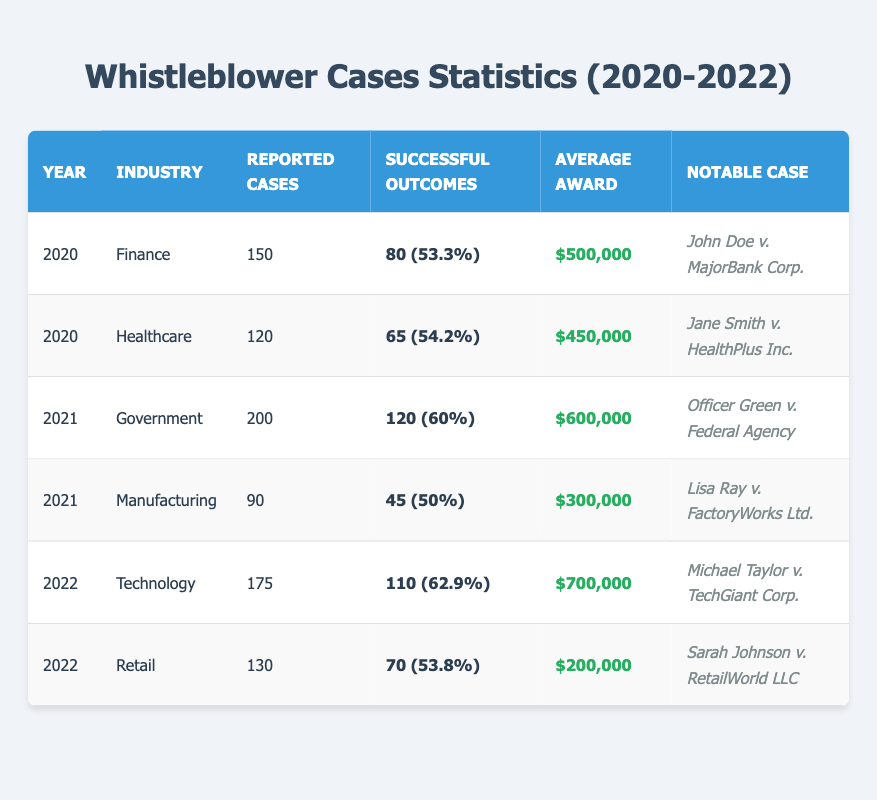What year had the highest number of reported whistleblower cases? By reviewing the "Reported Cases" column, the year 2021 shows the highest total of 200 reported cases in the Government industry.
Answer: 2021 What was the average award for whistleblower cases in 2022? Examining the "Average Award" column for the year 2022, there are two entries: $700,000 for Technology and $200,000 for Retail. To find the average, sum these amounts ($700,000 + $200,000 = $900,000) and divide by the number of cases (2), giving an average of $450,000.
Answer: $450,000 Is the success rate of the whistleblower cases in the Finance industry higher than 50% in 2020? The success rate for Finance cases in 2020 is 53.3%, which is indeed higher than 50%.
Answer: Yes How many successful outcomes were reported in the Healthcare industry in 2020? The table indicates there were 65 successful outcomes in the Healthcare industry for the year 2020.
Answer: 65 Which industry had the highest average award from 2020 to 2022? The average awards for each industry are $500,000 (Finance), $450,000 (Healthcare), $600,000 (Government), $300,000 (Manufacturing), $700,000 (Technology), and $200,000 (Retail). The highest among these is $700,000 from the Technology industry in 2022.
Answer: Technology What is the total number of reported cases across all industries in 2021? Summing reported cases from all industries for 2021 gives: 200 (Government) + 90 (Manufacturing) = 290 reported cases in total.
Answer: 290 Which notable case corresponds to the highest average award? The notable case with the highest average award is "Michael Taylor v. TechGiant Corp." from the Technology industry with an average award of $700,000.
Answer: Michael Taylor v. TechGiant Corp What percentage of reported cases were successful in the Government industry in 2021? For the Government industry in 2021, the successful outcomes were 120 out of 200 reported cases. The success rate is calculated as (120/200) * 100 = 60%.
Answer: 60% Find the total average award across all industries in 2020 and 2021. Adding the average awards for 2020 ($500,000 + $450,000) and for 2021 ($600,000 + $300,000) gives a total of $500,000 + $450,000 + $600,000 + $300,000 = $1,850,000. The average is then $1,850,000 / 4 = $462,500.
Answer: $462,500 Was the success rate in the Retail industry for 2022 lower than that in Healthcare for 2020? The success rate for Retail in 2022 is 53.8%, while for Healthcare in 2020, it is 54.2%. Since 53.8% is less than 54.2%, the answer is yes.
Answer: Yes 